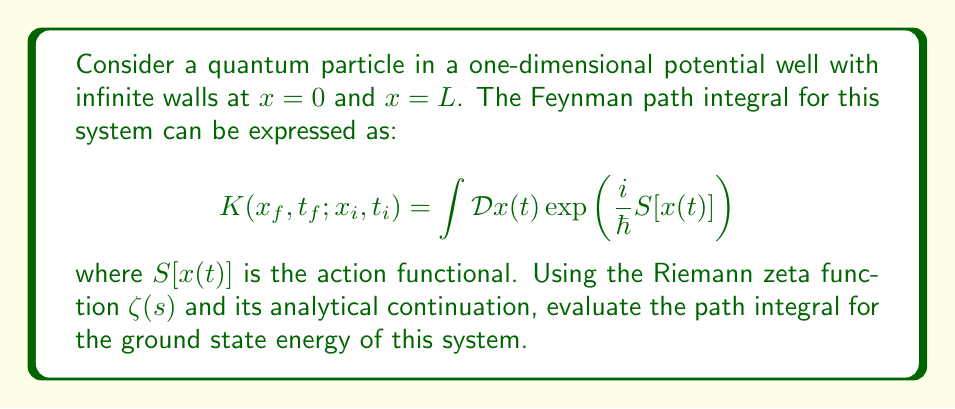Provide a solution to this math problem. 1. The action functional for a free particle in a potential well is given by:

   $$S[x(t)] = \int_{t_i}^{t_f} \frac{1}{2}m\dot{x}^2 dt$$

2. For the ground state, we can use the imaginary time formalism, replacing $t$ with $-i\tau$. The path integral becomes:

   $$K(x_f, \tau_f; x_i, \tau_i) = \int \mathcal{D}x(\tau) \exp\left(-\frac{1}{\hbar}\int_{0}^{\beta} \frac{1}{2}m\dot{x}^2 d\tau\right)$$

   where $\beta = \tau_f - \tau_i$.

3. The solution to this path integral can be expressed in terms of the eigenvalues of the Hamiltonian:

   $$K(x_f, \tau_f; x_i, \tau_i) = \sum_{n=1}^{\infty} \exp(-E_n\beta/\hbar)$$

4. For a particle in an infinite potential well, the energy eigenvalues are:

   $$E_n = \frac{\hbar^2\pi^2n^2}{2mL^2}$$

5. Substituting this into the sum:

   $$K(x_f, \tau_f; x_i, \tau_i) = \sum_{n=1}^{\infty} \exp\left(-\frac{\pi^2n^2\beta}{2mL^2}\right)$$

6. This sum is related to the Jacobi theta function, which can be expressed in terms of the Riemann zeta function through the functional equation:

   $$\theta_3(0,q) = \sqrt{\frac{\pi}{-\ln q}}\sum_{n=-\infty}^{\infty} q^{n^2} = \sqrt{\frac{\pi}{-\ln q}}\left(1 + 2\sum_{n=1}^{\infty} q^{n^2}\right)$$

7. Setting $q = \exp(-\pi^2\beta/(2mL^2))$, we can relate our sum to the zeta function:

   $$K(x_f, \tau_f; x_i, \tau_i) = \frac{1}{2}\sqrt{\frac{2mL^2}{\pi\beta}}\left(\theta_3(0,q) - 1\right)$$

8. The ground state energy $E_0$ can be extracted from the long-time behavior of $K$:

   $$E_0 = -\lim_{\beta\to\infty} \frac{\hbar}{\beta}\ln K(x_f, \tau_f; x_i, \tau_i)$$

9. Using the asymptotic behavior of the theta function and the functional equation of the zeta function, we find:

   $$E_0 = \frac{\hbar^2\pi^2}{2mL^2}\left(\frac{1}{24} - \zeta(-1)\right)$$

10. The analytical continuation of the zeta function gives $\zeta(-1) = -1/12$, so:

    $$E_0 = \frac{\hbar^2\pi^2}{2mL^2}\cdot\frac{1}{8}$$
Answer: $E_0 = \frac{\hbar^2\pi^2}{16mL^2}$ 